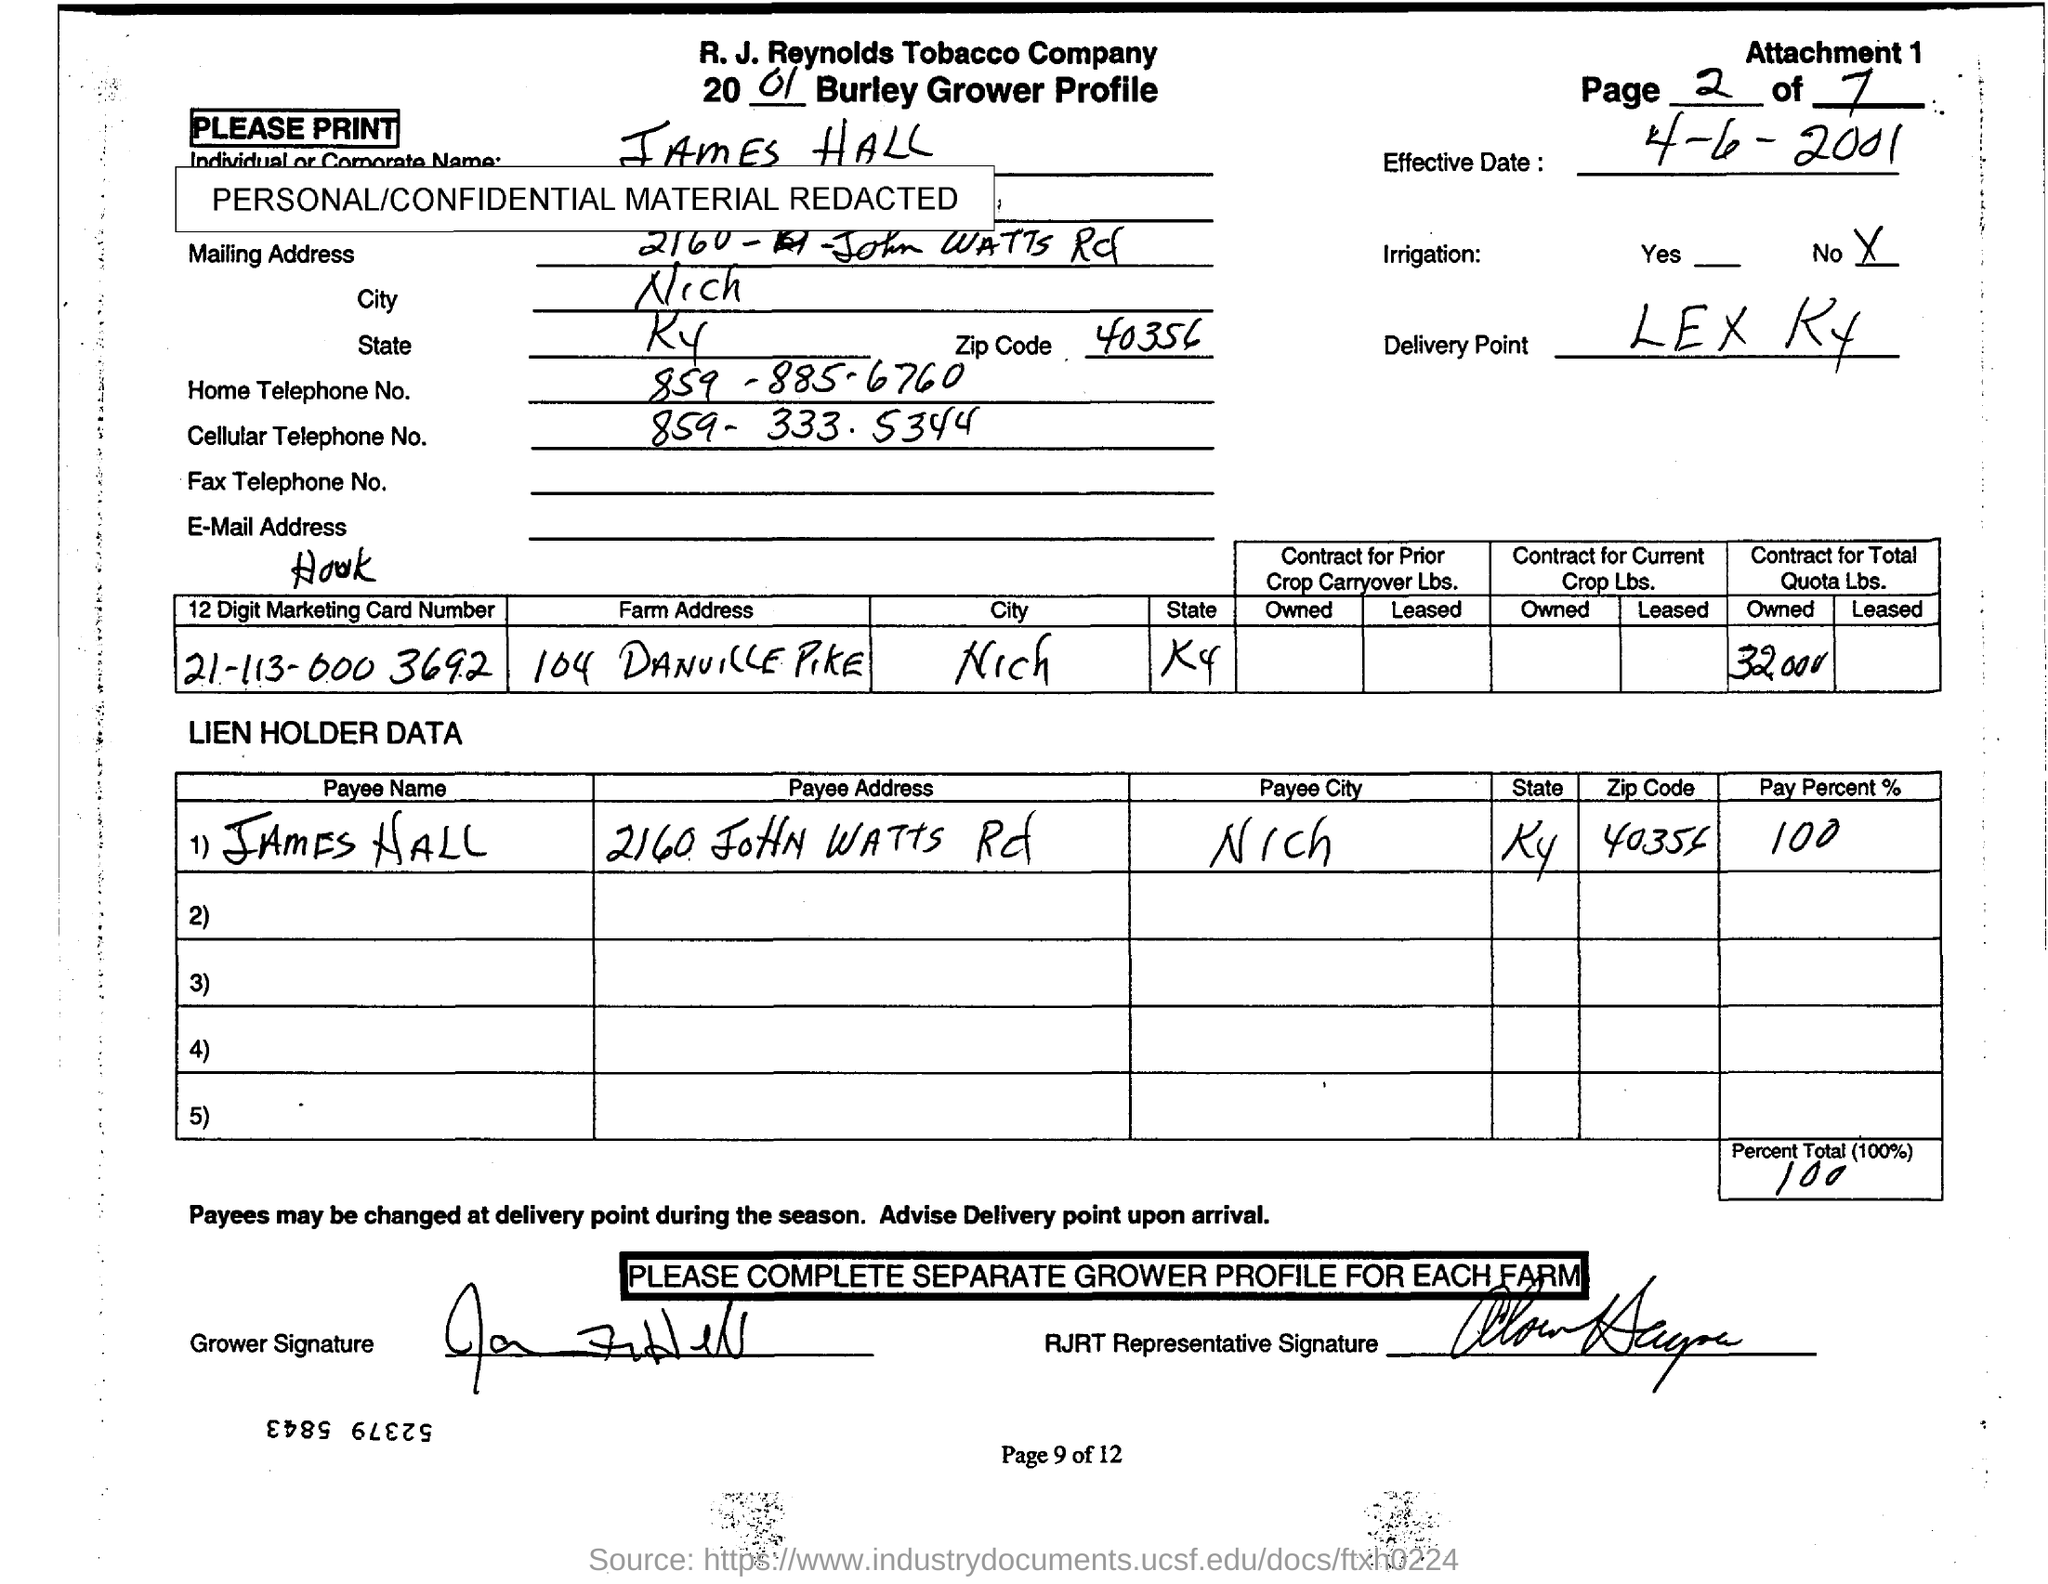How much is the "Percent Total (100%)"  value?
Ensure brevity in your answer.  100. What is the Zip code mentioned in Mailing Address of 'James Hall'?
Your response must be concise. 40356. What is the Home Telephone No. of 'James Hall' ?
Your answer should be very brief. 859-885-6760. What is the '12 Digit Marketing Card Number' written in first  column of first table?
Your answer should be very brief. 21-113-000 3692. Whose name is written in "Payee Name" column of second table?
Give a very brief answer. James Hall. Which date is mentioned as 'Effective Date:" in the document?
Provide a short and direct response. 4-6-2001. What is the 'Delivery Point' mentioned?
Offer a very short reply. LEX KY. Which is written as 'Payee City' in second table?
Provide a short and direct response. Nich. Which is the state mentioned under 'State' column of second table?
Provide a succinct answer. KY. 